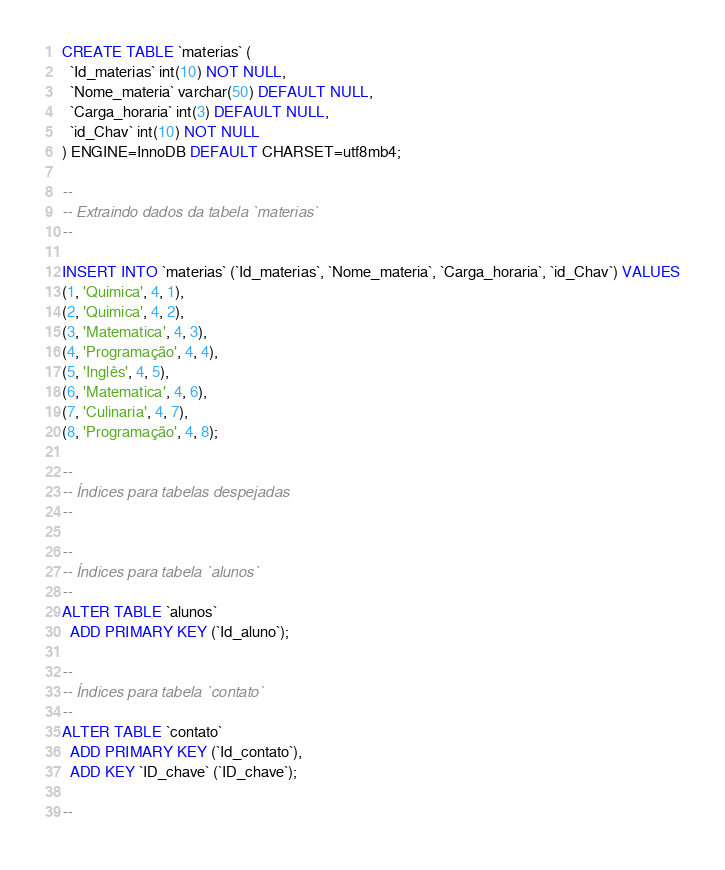<code> <loc_0><loc_0><loc_500><loc_500><_SQL_>CREATE TABLE `materias` (
  `Id_materias` int(10) NOT NULL,
  `Nome_materia` varchar(50) DEFAULT NULL,
  `Carga_horaria` int(3) DEFAULT NULL,
  `id_Chav` int(10) NOT NULL
) ENGINE=InnoDB DEFAULT CHARSET=utf8mb4;

--
-- Extraindo dados da tabela `materias`
--

INSERT INTO `materias` (`Id_materias`, `Nome_materia`, `Carga_horaria`, `id_Chav`) VALUES
(1, 'Quimica', 4, 1),
(2, 'Quimica', 4, 2),
(3, 'Matematica', 4, 3),
(4, 'Programação', 4, 4),
(5, 'Inglês', 4, 5),
(6, 'Matematica', 4, 6),
(7, 'Culinaria', 4, 7),
(8, 'Programação', 4, 8);

--
-- Índices para tabelas despejadas
--

--
-- Índices para tabela `alunos`
--
ALTER TABLE `alunos`
  ADD PRIMARY KEY (`Id_aluno`);

--
-- Índices para tabela `contato`
--
ALTER TABLE `contato`
  ADD PRIMARY KEY (`Id_contato`),
  ADD KEY `ID_chave` (`ID_chave`);

--</code> 